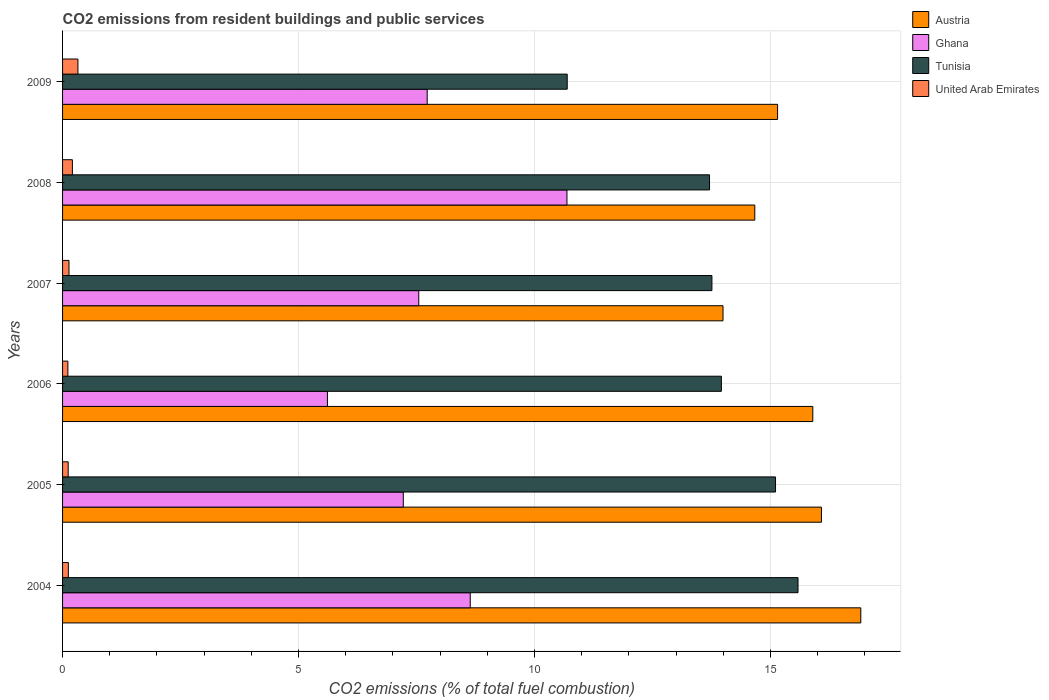How many different coloured bars are there?
Your answer should be very brief. 4. How many groups of bars are there?
Give a very brief answer. 6. Are the number of bars per tick equal to the number of legend labels?
Provide a succinct answer. Yes. In how many cases, is the number of bars for a given year not equal to the number of legend labels?
Give a very brief answer. 0. What is the total CO2 emitted in United Arab Emirates in 2005?
Offer a terse response. 0.12. Across all years, what is the maximum total CO2 emitted in Austria?
Make the answer very short. 16.91. Across all years, what is the minimum total CO2 emitted in Ghana?
Your response must be concise. 5.61. In which year was the total CO2 emitted in Austria minimum?
Offer a very short reply. 2007. What is the total total CO2 emitted in Tunisia in the graph?
Ensure brevity in your answer.  82.81. What is the difference between the total CO2 emitted in Austria in 2006 and that in 2007?
Provide a short and direct response. 1.9. What is the difference between the total CO2 emitted in Tunisia in 2008 and the total CO2 emitted in Austria in 2007?
Give a very brief answer. -0.29. What is the average total CO2 emitted in United Arab Emirates per year?
Give a very brief answer. 0.17. In the year 2004, what is the difference between the total CO2 emitted in United Arab Emirates and total CO2 emitted in Tunisia?
Provide a short and direct response. -15.46. What is the ratio of the total CO2 emitted in United Arab Emirates in 2004 to that in 2006?
Ensure brevity in your answer.  1.09. Is the total CO2 emitted in Austria in 2004 less than that in 2006?
Provide a short and direct response. No. What is the difference between the highest and the second highest total CO2 emitted in United Arab Emirates?
Ensure brevity in your answer.  0.12. What is the difference between the highest and the lowest total CO2 emitted in United Arab Emirates?
Provide a succinct answer. 0.21. In how many years, is the total CO2 emitted in Ghana greater than the average total CO2 emitted in Ghana taken over all years?
Make the answer very short. 2. Is the sum of the total CO2 emitted in Austria in 2008 and 2009 greater than the maximum total CO2 emitted in United Arab Emirates across all years?
Your answer should be compact. Yes. Is it the case that in every year, the sum of the total CO2 emitted in United Arab Emirates and total CO2 emitted in Ghana is greater than the sum of total CO2 emitted in Tunisia and total CO2 emitted in Austria?
Offer a terse response. No. What does the 2nd bar from the top in 2004 represents?
Give a very brief answer. Tunisia. What does the 3rd bar from the bottom in 2008 represents?
Give a very brief answer. Tunisia. How many years are there in the graph?
Give a very brief answer. 6. What is the difference between two consecutive major ticks on the X-axis?
Make the answer very short. 5. Does the graph contain any zero values?
Your answer should be compact. No. How many legend labels are there?
Keep it short and to the point. 4. What is the title of the graph?
Provide a short and direct response. CO2 emissions from resident buildings and public services. What is the label or title of the X-axis?
Give a very brief answer. CO2 emissions (% of total fuel combustion). What is the label or title of the Y-axis?
Provide a short and direct response. Years. What is the CO2 emissions (% of total fuel combustion) in Austria in 2004?
Ensure brevity in your answer.  16.91. What is the CO2 emissions (% of total fuel combustion) of Ghana in 2004?
Provide a succinct answer. 8.64. What is the CO2 emissions (% of total fuel combustion) of Tunisia in 2004?
Offer a terse response. 15.58. What is the CO2 emissions (% of total fuel combustion) in United Arab Emirates in 2004?
Offer a very short reply. 0.12. What is the CO2 emissions (% of total fuel combustion) of Austria in 2005?
Provide a short and direct response. 16.08. What is the CO2 emissions (% of total fuel combustion) in Ghana in 2005?
Give a very brief answer. 7.22. What is the CO2 emissions (% of total fuel combustion) of Tunisia in 2005?
Give a very brief answer. 15.11. What is the CO2 emissions (% of total fuel combustion) in United Arab Emirates in 2005?
Your response must be concise. 0.12. What is the CO2 emissions (% of total fuel combustion) of Austria in 2006?
Provide a succinct answer. 15.9. What is the CO2 emissions (% of total fuel combustion) of Ghana in 2006?
Offer a very short reply. 5.61. What is the CO2 emissions (% of total fuel combustion) in Tunisia in 2006?
Your answer should be very brief. 13.96. What is the CO2 emissions (% of total fuel combustion) in United Arab Emirates in 2006?
Make the answer very short. 0.11. What is the CO2 emissions (% of total fuel combustion) of Austria in 2007?
Ensure brevity in your answer.  13.99. What is the CO2 emissions (% of total fuel combustion) in Ghana in 2007?
Make the answer very short. 7.55. What is the CO2 emissions (% of total fuel combustion) of Tunisia in 2007?
Ensure brevity in your answer.  13.76. What is the CO2 emissions (% of total fuel combustion) in United Arab Emirates in 2007?
Your answer should be compact. 0.14. What is the CO2 emissions (% of total fuel combustion) in Austria in 2008?
Your response must be concise. 14.67. What is the CO2 emissions (% of total fuel combustion) in Ghana in 2008?
Provide a succinct answer. 10.69. What is the CO2 emissions (% of total fuel combustion) in Tunisia in 2008?
Keep it short and to the point. 13.71. What is the CO2 emissions (% of total fuel combustion) in United Arab Emirates in 2008?
Provide a short and direct response. 0.21. What is the CO2 emissions (% of total fuel combustion) of Austria in 2009?
Provide a succinct answer. 15.15. What is the CO2 emissions (% of total fuel combustion) in Ghana in 2009?
Your answer should be compact. 7.73. What is the CO2 emissions (% of total fuel combustion) in Tunisia in 2009?
Your answer should be compact. 10.69. What is the CO2 emissions (% of total fuel combustion) in United Arab Emirates in 2009?
Provide a short and direct response. 0.33. Across all years, what is the maximum CO2 emissions (% of total fuel combustion) of Austria?
Your answer should be very brief. 16.91. Across all years, what is the maximum CO2 emissions (% of total fuel combustion) of Ghana?
Your answer should be compact. 10.69. Across all years, what is the maximum CO2 emissions (% of total fuel combustion) in Tunisia?
Your response must be concise. 15.58. Across all years, what is the maximum CO2 emissions (% of total fuel combustion) of United Arab Emirates?
Offer a terse response. 0.33. Across all years, what is the minimum CO2 emissions (% of total fuel combustion) in Austria?
Ensure brevity in your answer.  13.99. Across all years, what is the minimum CO2 emissions (% of total fuel combustion) of Ghana?
Your answer should be compact. 5.61. Across all years, what is the minimum CO2 emissions (% of total fuel combustion) in Tunisia?
Provide a succinct answer. 10.69. Across all years, what is the minimum CO2 emissions (% of total fuel combustion) of United Arab Emirates?
Keep it short and to the point. 0.11. What is the total CO2 emissions (% of total fuel combustion) in Austria in the graph?
Your answer should be very brief. 92.7. What is the total CO2 emissions (% of total fuel combustion) in Ghana in the graph?
Keep it short and to the point. 47.43. What is the total CO2 emissions (% of total fuel combustion) in Tunisia in the graph?
Ensure brevity in your answer.  82.81. What is the total CO2 emissions (% of total fuel combustion) of United Arab Emirates in the graph?
Your response must be concise. 1.02. What is the difference between the CO2 emissions (% of total fuel combustion) of Austria in 2004 and that in 2005?
Your response must be concise. 0.83. What is the difference between the CO2 emissions (% of total fuel combustion) in Ghana in 2004 and that in 2005?
Your response must be concise. 1.42. What is the difference between the CO2 emissions (% of total fuel combustion) of Tunisia in 2004 and that in 2005?
Give a very brief answer. 0.48. What is the difference between the CO2 emissions (% of total fuel combustion) of United Arab Emirates in 2004 and that in 2005?
Offer a terse response. 0. What is the difference between the CO2 emissions (% of total fuel combustion) of Ghana in 2004 and that in 2006?
Offer a very short reply. 3.03. What is the difference between the CO2 emissions (% of total fuel combustion) in Tunisia in 2004 and that in 2006?
Give a very brief answer. 1.62. What is the difference between the CO2 emissions (% of total fuel combustion) of United Arab Emirates in 2004 and that in 2006?
Keep it short and to the point. 0.01. What is the difference between the CO2 emissions (% of total fuel combustion) of Austria in 2004 and that in 2007?
Provide a short and direct response. 2.92. What is the difference between the CO2 emissions (% of total fuel combustion) in Ghana in 2004 and that in 2007?
Offer a terse response. 1.09. What is the difference between the CO2 emissions (% of total fuel combustion) of Tunisia in 2004 and that in 2007?
Keep it short and to the point. 1.82. What is the difference between the CO2 emissions (% of total fuel combustion) in United Arab Emirates in 2004 and that in 2007?
Provide a short and direct response. -0.01. What is the difference between the CO2 emissions (% of total fuel combustion) of Austria in 2004 and that in 2008?
Make the answer very short. 2.25. What is the difference between the CO2 emissions (% of total fuel combustion) in Ghana in 2004 and that in 2008?
Offer a terse response. -2.05. What is the difference between the CO2 emissions (% of total fuel combustion) of Tunisia in 2004 and that in 2008?
Your answer should be very brief. 1.87. What is the difference between the CO2 emissions (% of total fuel combustion) of United Arab Emirates in 2004 and that in 2008?
Ensure brevity in your answer.  -0.09. What is the difference between the CO2 emissions (% of total fuel combustion) of Austria in 2004 and that in 2009?
Your answer should be compact. 1.76. What is the difference between the CO2 emissions (% of total fuel combustion) in Ghana in 2004 and that in 2009?
Your response must be concise. 0.91. What is the difference between the CO2 emissions (% of total fuel combustion) of Tunisia in 2004 and that in 2009?
Keep it short and to the point. 4.89. What is the difference between the CO2 emissions (% of total fuel combustion) in United Arab Emirates in 2004 and that in 2009?
Your response must be concise. -0.2. What is the difference between the CO2 emissions (% of total fuel combustion) in Austria in 2005 and that in 2006?
Provide a succinct answer. 0.18. What is the difference between the CO2 emissions (% of total fuel combustion) of Ghana in 2005 and that in 2006?
Ensure brevity in your answer.  1.61. What is the difference between the CO2 emissions (% of total fuel combustion) in Tunisia in 2005 and that in 2006?
Your answer should be compact. 1.15. What is the difference between the CO2 emissions (% of total fuel combustion) in United Arab Emirates in 2005 and that in 2006?
Your response must be concise. 0.01. What is the difference between the CO2 emissions (% of total fuel combustion) of Austria in 2005 and that in 2007?
Provide a succinct answer. 2.09. What is the difference between the CO2 emissions (% of total fuel combustion) of Ghana in 2005 and that in 2007?
Offer a terse response. -0.33. What is the difference between the CO2 emissions (% of total fuel combustion) of Tunisia in 2005 and that in 2007?
Your response must be concise. 1.35. What is the difference between the CO2 emissions (% of total fuel combustion) in United Arab Emirates in 2005 and that in 2007?
Your response must be concise. -0.02. What is the difference between the CO2 emissions (% of total fuel combustion) in Austria in 2005 and that in 2008?
Provide a short and direct response. 1.41. What is the difference between the CO2 emissions (% of total fuel combustion) in Ghana in 2005 and that in 2008?
Make the answer very short. -3.47. What is the difference between the CO2 emissions (% of total fuel combustion) in Tunisia in 2005 and that in 2008?
Make the answer very short. 1.4. What is the difference between the CO2 emissions (% of total fuel combustion) in United Arab Emirates in 2005 and that in 2008?
Provide a short and direct response. -0.09. What is the difference between the CO2 emissions (% of total fuel combustion) of Austria in 2005 and that in 2009?
Your answer should be compact. 0.93. What is the difference between the CO2 emissions (% of total fuel combustion) in Ghana in 2005 and that in 2009?
Your answer should be compact. -0.51. What is the difference between the CO2 emissions (% of total fuel combustion) in Tunisia in 2005 and that in 2009?
Offer a very short reply. 4.41. What is the difference between the CO2 emissions (% of total fuel combustion) of United Arab Emirates in 2005 and that in 2009?
Your response must be concise. -0.21. What is the difference between the CO2 emissions (% of total fuel combustion) in Austria in 2006 and that in 2007?
Give a very brief answer. 1.9. What is the difference between the CO2 emissions (% of total fuel combustion) of Ghana in 2006 and that in 2007?
Your answer should be very brief. -1.93. What is the difference between the CO2 emissions (% of total fuel combustion) in Tunisia in 2006 and that in 2007?
Your answer should be compact. 0.2. What is the difference between the CO2 emissions (% of total fuel combustion) in United Arab Emirates in 2006 and that in 2007?
Keep it short and to the point. -0.02. What is the difference between the CO2 emissions (% of total fuel combustion) of Austria in 2006 and that in 2008?
Offer a very short reply. 1.23. What is the difference between the CO2 emissions (% of total fuel combustion) of Ghana in 2006 and that in 2008?
Ensure brevity in your answer.  -5.07. What is the difference between the CO2 emissions (% of total fuel combustion) of Tunisia in 2006 and that in 2008?
Your answer should be compact. 0.25. What is the difference between the CO2 emissions (% of total fuel combustion) in United Arab Emirates in 2006 and that in 2008?
Provide a short and direct response. -0.1. What is the difference between the CO2 emissions (% of total fuel combustion) of Austria in 2006 and that in 2009?
Keep it short and to the point. 0.75. What is the difference between the CO2 emissions (% of total fuel combustion) in Ghana in 2006 and that in 2009?
Keep it short and to the point. -2.11. What is the difference between the CO2 emissions (% of total fuel combustion) in Tunisia in 2006 and that in 2009?
Provide a short and direct response. 3.27. What is the difference between the CO2 emissions (% of total fuel combustion) of United Arab Emirates in 2006 and that in 2009?
Offer a terse response. -0.21. What is the difference between the CO2 emissions (% of total fuel combustion) of Austria in 2007 and that in 2008?
Provide a short and direct response. -0.67. What is the difference between the CO2 emissions (% of total fuel combustion) of Ghana in 2007 and that in 2008?
Make the answer very short. -3.14. What is the difference between the CO2 emissions (% of total fuel combustion) of Tunisia in 2007 and that in 2008?
Your response must be concise. 0.05. What is the difference between the CO2 emissions (% of total fuel combustion) of United Arab Emirates in 2007 and that in 2008?
Offer a terse response. -0.07. What is the difference between the CO2 emissions (% of total fuel combustion) in Austria in 2007 and that in 2009?
Your response must be concise. -1.16. What is the difference between the CO2 emissions (% of total fuel combustion) of Ghana in 2007 and that in 2009?
Make the answer very short. -0.18. What is the difference between the CO2 emissions (% of total fuel combustion) in Tunisia in 2007 and that in 2009?
Give a very brief answer. 3.07. What is the difference between the CO2 emissions (% of total fuel combustion) of United Arab Emirates in 2007 and that in 2009?
Offer a very short reply. -0.19. What is the difference between the CO2 emissions (% of total fuel combustion) of Austria in 2008 and that in 2009?
Your answer should be compact. -0.48. What is the difference between the CO2 emissions (% of total fuel combustion) of Ghana in 2008 and that in 2009?
Your answer should be compact. 2.96. What is the difference between the CO2 emissions (% of total fuel combustion) of Tunisia in 2008 and that in 2009?
Offer a terse response. 3.02. What is the difference between the CO2 emissions (% of total fuel combustion) of United Arab Emirates in 2008 and that in 2009?
Keep it short and to the point. -0.12. What is the difference between the CO2 emissions (% of total fuel combustion) of Austria in 2004 and the CO2 emissions (% of total fuel combustion) of Ghana in 2005?
Your answer should be compact. 9.69. What is the difference between the CO2 emissions (% of total fuel combustion) in Austria in 2004 and the CO2 emissions (% of total fuel combustion) in Tunisia in 2005?
Provide a succinct answer. 1.81. What is the difference between the CO2 emissions (% of total fuel combustion) in Austria in 2004 and the CO2 emissions (% of total fuel combustion) in United Arab Emirates in 2005?
Provide a succinct answer. 16.79. What is the difference between the CO2 emissions (% of total fuel combustion) of Ghana in 2004 and the CO2 emissions (% of total fuel combustion) of Tunisia in 2005?
Provide a succinct answer. -6.47. What is the difference between the CO2 emissions (% of total fuel combustion) in Ghana in 2004 and the CO2 emissions (% of total fuel combustion) in United Arab Emirates in 2005?
Offer a terse response. 8.52. What is the difference between the CO2 emissions (% of total fuel combustion) of Tunisia in 2004 and the CO2 emissions (% of total fuel combustion) of United Arab Emirates in 2005?
Your response must be concise. 15.46. What is the difference between the CO2 emissions (% of total fuel combustion) of Austria in 2004 and the CO2 emissions (% of total fuel combustion) of Ghana in 2006?
Your answer should be compact. 11.3. What is the difference between the CO2 emissions (% of total fuel combustion) in Austria in 2004 and the CO2 emissions (% of total fuel combustion) in Tunisia in 2006?
Make the answer very short. 2.95. What is the difference between the CO2 emissions (% of total fuel combustion) of Austria in 2004 and the CO2 emissions (% of total fuel combustion) of United Arab Emirates in 2006?
Offer a very short reply. 16.8. What is the difference between the CO2 emissions (% of total fuel combustion) in Ghana in 2004 and the CO2 emissions (% of total fuel combustion) in Tunisia in 2006?
Offer a very short reply. -5.32. What is the difference between the CO2 emissions (% of total fuel combustion) of Ghana in 2004 and the CO2 emissions (% of total fuel combustion) of United Arab Emirates in 2006?
Offer a very short reply. 8.53. What is the difference between the CO2 emissions (% of total fuel combustion) in Tunisia in 2004 and the CO2 emissions (% of total fuel combustion) in United Arab Emirates in 2006?
Ensure brevity in your answer.  15.47. What is the difference between the CO2 emissions (% of total fuel combustion) of Austria in 2004 and the CO2 emissions (% of total fuel combustion) of Ghana in 2007?
Make the answer very short. 9.37. What is the difference between the CO2 emissions (% of total fuel combustion) in Austria in 2004 and the CO2 emissions (% of total fuel combustion) in Tunisia in 2007?
Give a very brief answer. 3.15. What is the difference between the CO2 emissions (% of total fuel combustion) in Austria in 2004 and the CO2 emissions (% of total fuel combustion) in United Arab Emirates in 2007?
Keep it short and to the point. 16.78. What is the difference between the CO2 emissions (% of total fuel combustion) in Ghana in 2004 and the CO2 emissions (% of total fuel combustion) in Tunisia in 2007?
Give a very brief answer. -5.12. What is the difference between the CO2 emissions (% of total fuel combustion) in Ghana in 2004 and the CO2 emissions (% of total fuel combustion) in United Arab Emirates in 2007?
Provide a succinct answer. 8.5. What is the difference between the CO2 emissions (% of total fuel combustion) in Tunisia in 2004 and the CO2 emissions (% of total fuel combustion) in United Arab Emirates in 2007?
Make the answer very short. 15.45. What is the difference between the CO2 emissions (% of total fuel combustion) of Austria in 2004 and the CO2 emissions (% of total fuel combustion) of Ghana in 2008?
Give a very brief answer. 6.23. What is the difference between the CO2 emissions (% of total fuel combustion) in Austria in 2004 and the CO2 emissions (% of total fuel combustion) in Tunisia in 2008?
Offer a terse response. 3.21. What is the difference between the CO2 emissions (% of total fuel combustion) of Austria in 2004 and the CO2 emissions (% of total fuel combustion) of United Arab Emirates in 2008?
Ensure brevity in your answer.  16.7. What is the difference between the CO2 emissions (% of total fuel combustion) in Ghana in 2004 and the CO2 emissions (% of total fuel combustion) in Tunisia in 2008?
Keep it short and to the point. -5.07. What is the difference between the CO2 emissions (% of total fuel combustion) in Ghana in 2004 and the CO2 emissions (% of total fuel combustion) in United Arab Emirates in 2008?
Offer a terse response. 8.43. What is the difference between the CO2 emissions (% of total fuel combustion) in Tunisia in 2004 and the CO2 emissions (% of total fuel combustion) in United Arab Emirates in 2008?
Offer a very short reply. 15.37. What is the difference between the CO2 emissions (% of total fuel combustion) in Austria in 2004 and the CO2 emissions (% of total fuel combustion) in Ghana in 2009?
Make the answer very short. 9.19. What is the difference between the CO2 emissions (% of total fuel combustion) in Austria in 2004 and the CO2 emissions (% of total fuel combustion) in Tunisia in 2009?
Offer a terse response. 6.22. What is the difference between the CO2 emissions (% of total fuel combustion) in Austria in 2004 and the CO2 emissions (% of total fuel combustion) in United Arab Emirates in 2009?
Ensure brevity in your answer.  16.59. What is the difference between the CO2 emissions (% of total fuel combustion) in Ghana in 2004 and the CO2 emissions (% of total fuel combustion) in Tunisia in 2009?
Offer a very short reply. -2.05. What is the difference between the CO2 emissions (% of total fuel combustion) of Ghana in 2004 and the CO2 emissions (% of total fuel combustion) of United Arab Emirates in 2009?
Give a very brief answer. 8.31. What is the difference between the CO2 emissions (% of total fuel combustion) in Tunisia in 2004 and the CO2 emissions (% of total fuel combustion) in United Arab Emirates in 2009?
Offer a very short reply. 15.26. What is the difference between the CO2 emissions (% of total fuel combustion) of Austria in 2005 and the CO2 emissions (% of total fuel combustion) of Ghana in 2006?
Provide a short and direct response. 10.47. What is the difference between the CO2 emissions (% of total fuel combustion) in Austria in 2005 and the CO2 emissions (% of total fuel combustion) in Tunisia in 2006?
Provide a short and direct response. 2.12. What is the difference between the CO2 emissions (% of total fuel combustion) of Austria in 2005 and the CO2 emissions (% of total fuel combustion) of United Arab Emirates in 2006?
Your answer should be compact. 15.97. What is the difference between the CO2 emissions (% of total fuel combustion) of Ghana in 2005 and the CO2 emissions (% of total fuel combustion) of Tunisia in 2006?
Keep it short and to the point. -6.74. What is the difference between the CO2 emissions (% of total fuel combustion) of Ghana in 2005 and the CO2 emissions (% of total fuel combustion) of United Arab Emirates in 2006?
Keep it short and to the point. 7.11. What is the difference between the CO2 emissions (% of total fuel combustion) in Tunisia in 2005 and the CO2 emissions (% of total fuel combustion) in United Arab Emirates in 2006?
Your answer should be compact. 14.99. What is the difference between the CO2 emissions (% of total fuel combustion) in Austria in 2005 and the CO2 emissions (% of total fuel combustion) in Ghana in 2007?
Your answer should be very brief. 8.53. What is the difference between the CO2 emissions (% of total fuel combustion) in Austria in 2005 and the CO2 emissions (% of total fuel combustion) in Tunisia in 2007?
Give a very brief answer. 2.32. What is the difference between the CO2 emissions (% of total fuel combustion) of Austria in 2005 and the CO2 emissions (% of total fuel combustion) of United Arab Emirates in 2007?
Your response must be concise. 15.94. What is the difference between the CO2 emissions (% of total fuel combustion) in Ghana in 2005 and the CO2 emissions (% of total fuel combustion) in Tunisia in 2007?
Ensure brevity in your answer.  -6.54. What is the difference between the CO2 emissions (% of total fuel combustion) in Ghana in 2005 and the CO2 emissions (% of total fuel combustion) in United Arab Emirates in 2007?
Offer a terse response. 7.08. What is the difference between the CO2 emissions (% of total fuel combustion) in Tunisia in 2005 and the CO2 emissions (% of total fuel combustion) in United Arab Emirates in 2007?
Your answer should be compact. 14.97. What is the difference between the CO2 emissions (% of total fuel combustion) of Austria in 2005 and the CO2 emissions (% of total fuel combustion) of Ghana in 2008?
Make the answer very short. 5.39. What is the difference between the CO2 emissions (% of total fuel combustion) in Austria in 2005 and the CO2 emissions (% of total fuel combustion) in Tunisia in 2008?
Keep it short and to the point. 2.37. What is the difference between the CO2 emissions (% of total fuel combustion) in Austria in 2005 and the CO2 emissions (% of total fuel combustion) in United Arab Emirates in 2008?
Your answer should be very brief. 15.87. What is the difference between the CO2 emissions (% of total fuel combustion) of Ghana in 2005 and the CO2 emissions (% of total fuel combustion) of Tunisia in 2008?
Provide a succinct answer. -6.49. What is the difference between the CO2 emissions (% of total fuel combustion) in Ghana in 2005 and the CO2 emissions (% of total fuel combustion) in United Arab Emirates in 2008?
Ensure brevity in your answer.  7.01. What is the difference between the CO2 emissions (% of total fuel combustion) in Tunisia in 2005 and the CO2 emissions (% of total fuel combustion) in United Arab Emirates in 2008?
Make the answer very short. 14.9. What is the difference between the CO2 emissions (% of total fuel combustion) of Austria in 2005 and the CO2 emissions (% of total fuel combustion) of Ghana in 2009?
Your response must be concise. 8.35. What is the difference between the CO2 emissions (% of total fuel combustion) of Austria in 2005 and the CO2 emissions (% of total fuel combustion) of Tunisia in 2009?
Give a very brief answer. 5.39. What is the difference between the CO2 emissions (% of total fuel combustion) of Austria in 2005 and the CO2 emissions (% of total fuel combustion) of United Arab Emirates in 2009?
Offer a very short reply. 15.75. What is the difference between the CO2 emissions (% of total fuel combustion) of Ghana in 2005 and the CO2 emissions (% of total fuel combustion) of Tunisia in 2009?
Offer a terse response. -3.47. What is the difference between the CO2 emissions (% of total fuel combustion) in Ghana in 2005 and the CO2 emissions (% of total fuel combustion) in United Arab Emirates in 2009?
Your answer should be very brief. 6.89. What is the difference between the CO2 emissions (% of total fuel combustion) of Tunisia in 2005 and the CO2 emissions (% of total fuel combustion) of United Arab Emirates in 2009?
Provide a succinct answer. 14.78. What is the difference between the CO2 emissions (% of total fuel combustion) of Austria in 2006 and the CO2 emissions (% of total fuel combustion) of Ghana in 2007?
Your response must be concise. 8.35. What is the difference between the CO2 emissions (% of total fuel combustion) in Austria in 2006 and the CO2 emissions (% of total fuel combustion) in Tunisia in 2007?
Offer a terse response. 2.14. What is the difference between the CO2 emissions (% of total fuel combustion) in Austria in 2006 and the CO2 emissions (% of total fuel combustion) in United Arab Emirates in 2007?
Your answer should be compact. 15.76. What is the difference between the CO2 emissions (% of total fuel combustion) in Ghana in 2006 and the CO2 emissions (% of total fuel combustion) in Tunisia in 2007?
Make the answer very short. -8.15. What is the difference between the CO2 emissions (% of total fuel combustion) of Ghana in 2006 and the CO2 emissions (% of total fuel combustion) of United Arab Emirates in 2007?
Offer a very short reply. 5.48. What is the difference between the CO2 emissions (% of total fuel combustion) of Tunisia in 2006 and the CO2 emissions (% of total fuel combustion) of United Arab Emirates in 2007?
Give a very brief answer. 13.82. What is the difference between the CO2 emissions (% of total fuel combustion) of Austria in 2006 and the CO2 emissions (% of total fuel combustion) of Ghana in 2008?
Keep it short and to the point. 5.21. What is the difference between the CO2 emissions (% of total fuel combustion) in Austria in 2006 and the CO2 emissions (% of total fuel combustion) in Tunisia in 2008?
Provide a short and direct response. 2.19. What is the difference between the CO2 emissions (% of total fuel combustion) of Austria in 2006 and the CO2 emissions (% of total fuel combustion) of United Arab Emirates in 2008?
Your answer should be very brief. 15.69. What is the difference between the CO2 emissions (% of total fuel combustion) in Ghana in 2006 and the CO2 emissions (% of total fuel combustion) in Tunisia in 2008?
Make the answer very short. -8.1. What is the difference between the CO2 emissions (% of total fuel combustion) of Ghana in 2006 and the CO2 emissions (% of total fuel combustion) of United Arab Emirates in 2008?
Provide a succinct answer. 5.4. What is the difference between the CO2 emissions (% of total fuel combustion) of Tunisia in 2006 and the CO2 emissions (% of total fuel combustion) of United Arab Emirates in 2008?
Provide a succinct answer. 13.75. What is the difference between the CO2 emissions (% of total fuel combustion) of Austria in 2006 and the CO2 emissions (% of total fuel combustion) of Ghana in 2009?
Provide a short and direct response. 8.17. What is the difference between the CO2 emissions (% of total fuel combustion) in Austria in 2006 and the CO2 emissions (% of total fuel combustion) in Tunisia in 2009?
Provide a succinct answer. 5.2. What is the difference between the CO2 emissions (% of total fuel combustion) of Austria in 2006 and the CO2 emissions (% of total fuel combustion) of United Arab Emirates in 2009?
Your response must be concise. 15.57. What is the difference between the CO2 emissions (% of total fuel combustion) of Ghana in 2006 and the CO2 emissions (% of total fuel combustion) of Tunisia in 2009?
Keep it short and to the point. -5.08. What is the difference between the CO2 emissions (% of total fuel combustion) of Ghana in 2006 and the CO2 emissions (% of total fuel combustion) of United Arab Emirates in 2009?
Offer a very short reply. 5.29. What is the difference between the CO2 emissions (% of total fuel combustion) in Tunisia in 2006 and the CO2 emissions (% of total fuel combustion) in United Arab Emirates in 2009?
Keep it short and to the point. 13.63. What is the difference between the CO2 emissions (% of total fuel combustion) in Austria in 2007 and the CO2 emissions (% of total fuel combustion) in Ghana in 2008?
Provide a short and direct response. 3.31. What is the difference between the CO2 emissions (% of total fuel combustion) in Austria in 2007 and the CO2 emissions (% of total fuel combustion) in Tunisia in 2008?
Your answer should be compact. 0.29. What is the difference between the CO2 emissions (% of total fuel combustion) in Austria in 2007 and the CO2 emissions (% of total fuel combustion) in United Arab Emirates in 2008?
Your response must be concise. 13.79. What is the difference between the CO2 emissions (% of total fuel combustion) of Ghana in 2007 and the CO2 emissions (% of total fuel combustion) of Tunisia in 2008?
Make the answer very short. -6.16. What is the difference between the CO2 emissions (% of total fuel combustion) in Ghana in 2007 and the CO2 emissions (% of total fuel combustion) in United Arab Emirates in 2008?
Offer a terse response. 7.34. What is the difference between the CO2 emissions (% of total fuel combustion) of Tunisia in 2007 and the CO2 emissions (% of total fuel combustion) of United Arab Emirates in 2008?
Your response must be concise. 13.55. What is the difference between the CO2 emissions (% of total fuel combustion) in Austria in 2007 and the CO2 emissions (% of total fuel combustion) in Ghana in 2009?
Your answer should be very brief. 6.27. What is the difference between the CO2 emissions (% of total fuel combustion) in Austria in 2007 and the CO2 emissions (% of total fuel combustion) in Tunisia in 2009?
Make the answer very short. 3.3. What is the difference between the CO2 emissions (% of total fuel combustion) of Austria in 2007 and the CO2 emissions (% of total fuel combustion) of United Arab Emirates in 2009?
Ensure brevity in your answer.  13.67. What is the difference between the CO2 emissions (% of total fuel combustion) of Ghana in 2007 and the CO2 emissions (% of total fuel combustion) of Tunisia in 2009?
Keep it short and to the point. -3.15. What is the difference between the CO2 emissions (% of total fuel combustion) in Ghana in 2007 and the CO2 emissions (% of total fuel combustion) in United Arab Emirates in 2009?
Make the answer very short. 7.22. What is the difference between the CO2 emissions (% of total fuel combustion) of Tunisia in 2007 and the CO2 emissions (% of total fuel combustion) of United Arab Emirates in 2009?
Give a very brief answer. 13.43. What is the difference between the CO2 emissions (% of total fuel combustion) in Austria in 2008 and the CO2 emissions (% of total fuel combustion) in Ghana in 2009?
Offer a terse response. 6.94. What is the difference between the CO2 emissions (% of total fuel combustion) in Austria in 2008 and the CO2 emissions (% of total fuel combustion) in Tunisia in 2009?
Ensure brevity in your answer.  3.97. What is the difference between the CO2 emissions (% of total fuel combustion) of Austria in 2008 and the CO2 emissions (% of total fuel combustion) of United Arab Emirates in 2009?
Provide a short and direct response. 14.34. What is the difference between the CO2 emissions (% of total fuel combustion) of Ghana in 2008 and the CO2 emissions (% of total fuel combustion) of Tunisia in 2009?
Provide a short and direct response. -0.01. What is the difference between the CO2 emissions (% of total fuel combustion) in Ghana in 2008 and the CO2 emissions (% of total fuel combustion) in United Arab Emirates in 2009?
Ensure brevity in your answer.  10.36. What is the difference between the CO2 emissions (% of total fuel combustion) of Tunisia in 2008 and the CO2 emissions (% of total fuel combustion) of United Arab Emirates in 2009?
Provide a short and direct response. 13.38. What is the average CO2 emissions (% of total fuel combustion) in Austria per year?
Offer a terse response. 15.45. What is the average CO2 emissions (% of total fuel combustion) of Ghana per year?
Make the answer very short. 7.91. What is the average CO2 emissions (% of total fuel combustion) in Tunisia per year?
Your answer should be compact. 13.8. What is the average CO2 emissions (% of total fuel combustion) of United Arab Emirates per year?
Offer a very short reply. 0.17. In the year 2004, what is the difference between the CO2 emissions (% of total fuel combustion) of Austria and CO2 emissions (% of total fuel combustion) of Ghana?
Make the answer very short. 8.28. In the year 2004, what is the difference between the CO2 emissions (% of total fuel combustion) of Austria and CO2 emissions (% of total fuel combustion) of Tunisia?
Your answer should be very brief. 1.33. In the year 2004, what is the difference between the CO2 emissions (% of total fuel combustion) of Austria and CO2 emissions (% of total fuel combustion) of United Arab Emirates?
Keep it short and to the point. 16.79. In the year 2004, what is the difference between the CO2 emissions (% of total fuel combustion) of Ghana and CO2 emissions (% of total fuel combustion) of Tunisia?
Provide a succinct answer. -6.95. In the year 2004, what is the difference between the CO2 emissions (% of total fuel combustion) in Ghana and CO2 emissions (% of total fuel combustion) in United Arab Emirates?
Keep it short and to the point. 8.52. In the year 2004, what is the difference between the CO2 emissions (% of total fuel combustion) of Tunisia and CO2 emissions (% of total fuel combustion) of United Arab Emirates?
Make the answer very short. 15.46. In the year 2005, what is the difference between the CO2 emissions (% of total fuel combustion) in Austria and CO2 emissions (% of total fuel combustion) in Ghana?
Offer a terse response. 8.86. In the year 2005, what is the difference between the CO2 emissions (% of total fuel combustion) of Austria and CO2 emissions (% of total fuel combustion) of Tunisia?
Make the answer very short. 0.97. In the year 2005, what is the difference between the CO2 emissions (% of total fuel combustion) in Austria and CO2 emissions (% of total fuel combustion) in United Arab Emirates?
Make the answer very short. 15.96. In the year 2005, what is the difference between the CO2 emissions (% of total fuel combustion) in Ghana and CO2 emissions (% of total fuel combustion) in Tunisia?
Keep it short and to the point. -7.89. In the year 2005, what is the difference between the CO2 emissions (% of total fuel combustion) of Ghana and CO2 emissions (% of total fuel combustion) of United Arab Emirates?
Your answer should be compact. 7.1. In the year 2005, what is the difference between the CO2 emissions (% of total fuel combustion) of Tunisia and CO2 emissions (% of total fuel combustion) of United Arab Emirates?
Give a very brief answer. 14.99. In the year 2006, what is the difference between the CO2 emissions (% of total fuel combustion) of Austria and CO2 emissions (% of total fuel combustion) of Ghana?
Your answer should be very brief. 10.28. In the year 2006, what is the difference between the CO2 emissions (% of total fuel combustion) in Austria and CO2 emissions (% of total fuel combustion) in Tunisia?
Offer a very short reply. 1.94. In the year 2006, what is the difference between the CO2 emissions (% of total fuel combustion) in Austria and CO2 emissions (% of total fuel combustion) in United Arab Emirates?
Ensure brevity in your answer.  15.78. In the year 2006, what is the difference between the CO2 emissions (% of total fuel combustion) of Ghana and CO2 emissions (% of total fuel combustion) of Tunisia?
Keep it short and to the point. -8.35. In the year 2006, what is the difference between the CO2 emissions (% of total fuel combustion) of Ghana and CO2 emissions (% of total fuel combustion) of United Arab Emirates?
Keep it short and to the point. 5.5. In the year 2006, what is the difference between the CO2 emissions (% of total fuel combustion) of Tunisia and CO2 emissions (% of total fuel combustion) of United Arab Emirates?
Offer a very short reply. 13.85. In the year 2007, what is the difference between the CO2 emissions (% of total fuel combustion) of Austria and CO2 emissions (% of total fuel combustion) of Ghana?
Your response must be concise. 6.45. In the year 2007, what is the difference between the CO2 emissions (% of total fuel combustion) in Austria and CO2 emissions (% of total fuel combustion) in Tunisia?
Offer a very short reply. 0.24. In the year 2007, what is the difference between the CO2 emissions (% of total fuel combustion) in Austria and CO2 emissions (% of total fuel combustion) in United Arab Emirates?
Your answer should be very brief. 13.86. In the year 2007, what is the difference between the CO2 emissions (% of total fuel combustion) in Ghana and CO2 emissions (% of total fuel combustion) in Tunisia?
Offer a very short reply. -6.21. In the year 2007, what is the difference between the CO2 emissions (% of total fuel combustion) of Ghana and CO2 emissions (% of total fuel combustion) of United Arab Emirates?
Your response must be concise. 7.41. In the year 2007, what is the difference between the CO2 emissions (% of total fuel combustion) in Tunisia and CO2 emissions (% of total fuel combustion) in United Arab Emirates?
Make the answer very short. 13.62. In the year 2008, what is the difference between the CO2 emissions (% of total fuel combustion) of Austria and CO2 emissions (% of total fuel combustion) of Ghana?
Ensure brevity in your answer.  3.98. In the year 2008, what is the difference between the CO2 emissions (% of total fuel combustion) in Austria and CO2 emissions (% of total fuel combustion) in Tunisia?
Give a very brief answer. 0.96. In the year 2008, what is the difference between the CO2 emissions (% of total fuel combustion) in Austria and CO2 emissions (% of total fuel combustion) in United Arab Emirates?
Keep it short and to the point. 14.46. In the year 2008, what is the difference between the CO2 emissions (% of total fuel combustion) in Ghana and CO2 emissions (% of total fuel combustion) in Tunisia?
Give a very brief answer. -3.02. In the year 2008, what is the difference between the CO2 emissions (% of total fuel combustion) of Ghana and CO2 emissions (% of total fuel combustion) of United Arab Emirates?
Make the answer very short. 10.48. In the year 2008, what is the difference between the CO2 emissions (% of total fuel combustion) of Tunisia and CO2 emissions (% of total fuel combustion) of United Arab Emirates?
Provide a succinct answer. 13.5. In the year 2009, what is the difference between the CO2 emissions (% of total fuel combustion) of Austria and CO2 emissions (% of total fuel combustion) of Ghana?
Your answer should be compact. 7.42. In the year 2009, what is the difference between the CO2 emissions (% of total fuel combustion) of Austria and CO2 emissions (% of total fuel combustion) of Tunisia?
Make the answer very short. 4.46. In the year 2009, what is the difference between the CO2 emissions (% of total fuel combustion) in Austria and CO2 emissions (% of total fuel combustion) in United Arab Emirates?
Offer a very short reply. 14.82. In the year 2009, what is the difference between the CO2 emissions (% of total fuel combustion) in Ghana and CO2 emissions (% of total fuel combustion) in Tunisia?
Ensure brevity in your answer.  -2.97. In the year 2009, what is the difference between the CO2 emissions (% of total fuel combustion) of Ghana and CO2 emissions (% of total fuel combustion) of United Arab Emirates?
Offer a very short reply. 7.4. In the year 2009, what is the difference between the CO2 emissions (% of total fuel combustion) of Tunisia and CO2 emissions (% of total fuel combustion) of United Arab Emirates?
Your answer should be compact. 10.37. What is the ratio of the CO2 emissions (% of total fuel combustion) in Austria in 2004 to that in 2005?
Your answer should be very brief. 1.05. What is the ratio of the CO2 emissions (% of total fuel combustion) of Ghana in 2004 to that in 2005?
Your answer should be very brief. 1.2. What is the ratio of the CO2 emissions (% of total fuel combustion) of Tunisia in 2004 to that in 2005?
Your answer should be compact. 1.03. What is the ratio of the CO2 emissions (% of total fuel combustion) in United Arab Emirates in 2004 to that in 2005?
Provide a short and direct response. 1.03. What is the ratio of the CO2 emissions (% of total fuel combustion) in Austria in 2004 to that in 2006?
Your answer should be very brief. 1.06. What is the ratio of the CO2 emissions (% of total fuel combustion) in Ghana in 2004 to that in 2006?
Offer a very short reply. 1.54. What is the ratio of the CO2 emissions (% of total fuel combustion) in Tunisia in 2004 to that in 2006?
Your answer should be very brief. 1.12. What is the ratio of the CO2 emissions (% of total fuel combustion) in United Arab Emirates in 2004 to that in 2006?
Make the answer very short. 1.09. What is the ratio of the CO2 emissions (% of total fuel combustion) of Austria in 2004 to that in 2007?
Your response must be concise. 1.21. What is the ratio of the CO2 emissions (% of total fuel combustion) in Ghana in 2004 to that in 2007?
Provide a succinct answer. 1.14. What is the ratio of the CO2 emissions (% of total fuel combustion) in Tunisia in 2004 to that in 2007?
Ensure brevity in your answer.  1.13. What is the ratio of the CO2 emissions (% of total fuel combustion) of United Arab Emirates in 2004 to that in 2007?
Ensure brevity in your answer.  0.9. What is the ratio of the CO2 emissions (% of total fuel combustion) in Austria in 2004 to that in 2008?
Keep it short and to the point. 1.15. What is the ratio of the CO2 emissions (% of total fuel combustion) in Ghana in 2004 to that in 2008?
Your answer should be very brief. 0.81. What is the ratio of the CO2 emissions (% of total fuel combustion) of Tunisia in 2004 to that in 2008?
Offer a very short reply. 1.14. What is the ratio of the CO2 emissions (% of total fuel combustion) of United Arab Emirates in 2004 to that in 2008?
Provide a short and direct response. 0.59. What is the ratio of the CO2 emissions (% of total fuel combustion) in Austria in 2004 to that in 2009?
Your answer should be compact. 1.12. What is the ratio of the CO2 emissions (% of total fuel combustion) of Ghana in 2004 to that in 2009?
Offer a terse response. 1.12. What is the ratio of the CO2 emissions (% of total fuel combustion) of Tunisia in 2004 to that in 2009?
Your response must be concise. 1.46. What is the ratio of the CO2 emissions (% of total fuel combustion) in United Arab Emirates in 2004 to that in 2009?
Ensure brevity in your answer.  0.38. What is the ratio of the CO2 emissions (% of total fuel combustion) in Austria in 2005 to that in 2006?
Your answer should be very brief. 1.01. What is the ratio of the CO2 emissions (% of total fuel combustion) in Ghana in 2005 to that in 2006?
Keep it short and to the point. 1.29. What is the ratio of the CO2 emissions (% of total fuel combustion) in Tunisia in 2005 to that in 2006?
Provide a succinct answer. 1.08. What is the ratio of the CO2 emissions (% of total fuel combustion) of United Arab Emirates in 2005 to that in 2006?
Provide a succinct answer. 1.06. What is the ratio of the CO2 emissions (% of total fuel combustion) of Austria in 2005 to that in 2007?
Make the answer very short. 1.15. What is the ratio of the CO2 emissions (% of total fuel combustion) in Ghana in 2005 to that in 2007?
Your answer should be compact. 0.96. What is the ratio of the CO2 emissions (% of total fuel combustion) in Tunisia in 2005 to that in 2007?
Give a very brief answer. 1.1. What is the ratio of the CO2 emissions (% of total fuel combustion) of United Arab Emirates in 2005 to that in 2007?
Ensure brevity in your answer.  0.88. What is the ratio of the CO2 emissions (% of total fuel combustion) in Austria in 2005 to that in 2008?
Make the answer very short. 1.1. What is the ratio of the CO2 emissions (% of total fuel combustion) in Ghana in 2005 to that in 2008?
Give a very brief answer. 0.68. What is the ratio of the CO2 emissions (% of total fuel combustion) of Tunisia in 2005 to that in 2008?
Provide a short and direct response. 1.1. What is the ratio of the CO2 emissions (% of total fuel combustion) in United Arab Emirates in 2005 to that in 2008?
Ensure brevity in your answer.  0.57. What is the ratio of the CO2 emissions (% of total fuel combustion) of Austria in 2005 to that in 2009?
Give a very brief answer. 1.06. What is the ratio of the CO2 emissions (% of total fuel combustion) in Ghana in 2005 to that in 2009?
Give a very brief answer. 0.93. What is the ratio of the CO2 emissions (% of total fuel combustion) in Tunisia in 2005 to that in 2009?
Offer a terse response. 1.41. What is the ratio of the CO2 emissions (% of total fuel combustion) in United Arab Emirates in 2005 to that in 2009?
Provide a succinct answer. 0.37. What is the ratio of the CO2 emissions (% of total fuel combustion) of Austria in 2006 to that in 2007?
Your response must be concise. 1.14. What is the ratio of the CO2 emissions (% of total fuel combustion) of Ghana in 2006 to that in 2007?
Your answer should be very brief. 0.74. What is the ratio of the CO2 emissions (% of total fuel combustion) in Tunisia in 2006 to that in 2007?
Your answer should be very brief. 1.01. What is the ratio of the CO2 emissions (% of total fuel combustion) of United Arab Emirates in 2006 to that in 2007?
Provide a succinct answer. 0.83. What is the ratio of the CO2 emissions (% of total fuel combustion) of Austria in 2006 to that in 2008?
Your answer should be compact. 1.08. What is the ratio of the CO2 emissions (% of total fuel combustion) of Ghana in 2006 to that in 2008?
Give a very brief answer. 0.53. What is the ratio of the CO2 emissions (% of total fuel combustion) in Tunisia in 2006 to that in 2008?
Keep it short and to the point. 1.02. What is the ratio of the CO2 emissions (% of total fuel combustion) in United Arab Emirates in 2006 to that in 2008?
Your answer should be compact. 0.54. What is the ratio of the CO2 emissions (% of total fuel combustion) of Austria in 2006 to that in 2009?
Keep it short and to the point. 1.05. What is the ratio of the CO2 emissions (% of total fuel combustion) of Ghana in 2006 to that in 2009?
Your answer should be compact. 0.73. What is the ratio of the CO2 emissions (% of total fuel combustion) in Tunisia in 2006 to that in 2009?
Your answer should be compact. 1.31. What is the ratio of the CO2 emissions (% of total fuel combustion) in United Arab Emirates in 2006 to that in 2009?
Offer a terse response. 0.35. What is the ratio of the CO2 emissions (% of total fuel combustion) of Austria in 2007 to that in 2008?
Keep it short and to the point. 0.95. What is the ratio of the CO2 emissions (% of total fuel combustion) in Ghana in 2007 to that in 2008?
Provide a short and direct response. 0.71. What is the ratio of the CO2 emissions (% of total fuel combustion) of Tunisia in 2007 to that in 2008?
Offer a terse response. 1. What is the ratio of the CO2 emissions (% of total fuel combustion) of United Arab Emirates in 2007 to that in 2008?
Offer a very short reply. 0.65. What is the ratio of the CO2 emissions (% of total fuel combustion) of Austria in 2007 to that in 2009?
Keep it short and to the point. 0.92. What is the ratio of the CO2 emissions (% of total fuel combustion) of Ghana in 2007 to that in 2009?
Make the answer very short. 0.98. What is the ratio of the CO2 emissions (% of total fuel combustion) in Tunisia in 2007 to that in 2009?
Your response must be concise. 1.29. What is the ratio of the CO2 emissions (% of total fuel combustion) in United Arab Emirates in 2007 to that in 2009?
Make the answer very short. 0.42. What is the ratio of the CO2 emissions (% of total fuel combustion) in Austria in 2008 to that in 2009?
Make the answer very short. 0.97. What is the ratio of the CO2 emissions (% of total fuel combustion) of Ghana in 2008 to that in 2009?
Your answer should be compact. 1.38. What is the ratio of the CO2 emissions (% of total fuel combustion) in Tunisia in 2008 to that in 2009?
Offer a terse response. 1.28. What is the ratio of the CO2 emissions (% of total fuel combustion) of United Arab Emirates in 2008 to that in 2009?
Ensure brevity in your answer.  0.64. What is the difference between the highest and the second highest CO2 emissions (% of total fuel combustion) of Austria?
Offer a very short reply. 0.83. What is the difference between the highest and the second highest CO2 emissions (% of total fuel combustion) of Ghana?
Provide a short and direct response. 2.05. What is the difference between the highest and the second highest CO2 emissions (% of total fuel combustion) of Tunisia?
Your answer should be compact. 0.48. What is the difference between the highest and the second highest CO2 emissions (% of total fuel combustion) of United Arab Emirates?
Give a very brief answer. 0.12. What is the difference between the highest and the lowest CO2 emissions (% of total fuel combustion) in Austria?
Provide a succinct answer. 2.92. What is the difference between the highest and the lowest CO2 emissions (% of total fuel combustion) in Ghana?
Ensure brevity in your answer.  5.07. What is the difference between the highest and the lowest CO2 emissions (% of total fuel combustion) in Tunisia?
Your answer should be very brief. 4.89. What is the difference between the highest and the lowest CO2 emissions (% of total fuel combustion) of United Arab Emirates?
Give a very brief answer. 0.21. 